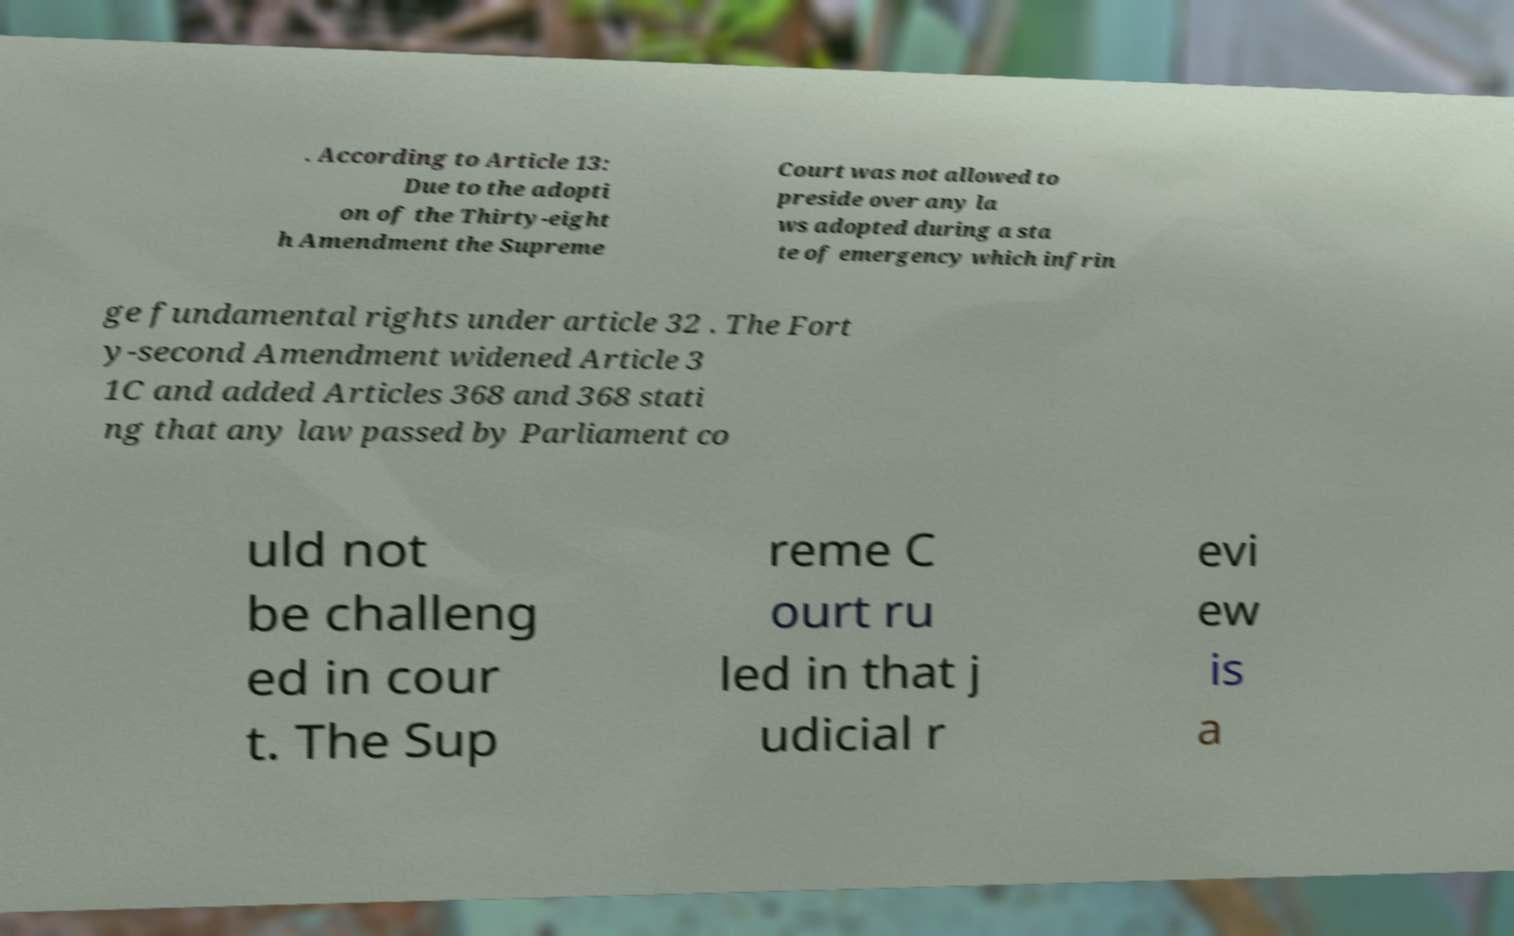Can you read and provide the text displayed in the image?This photo seems to have some interesting text. Can you extract and type it out for me? . According to Article 13: Due to the adopti on of the Thirty-eight h Amendment the Supreme Court was not allowed to preside over any la ws adopted during a sta te of emergency which infrin ge fundamental rights under article 32 . The Fort y-second Amendment widened Article 3 1C and added Articles 368 and 368 stati ng that any law passed by Parliament co uld not be challeng ed in cour t. The Sup reme C ourt ru led in that j udicial r evi ew is a 